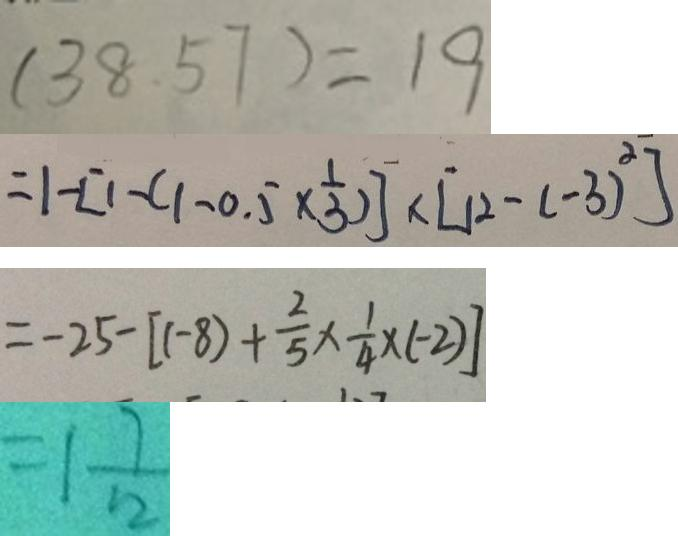Convert formula to latex. <formula><loc_0><loc_0><loc_500><loc_500>( 3 8 . 5 7 ) = 1 9 
 = 1 - [ 1 - ( 1 - 0 . 5 \times \frac { 1 } { 3 } ) ] \times [ 1 2 - ( - 3 ) ^ { 2 } ] 
 = - 2 5 - [ ( - 8 ) + \frac { 2 } { 5 } \times \frac { 1 } { 4 } \times ( - 2 ) ] 
 = 1 \frac { 7 } { 1 2 }</formula> 